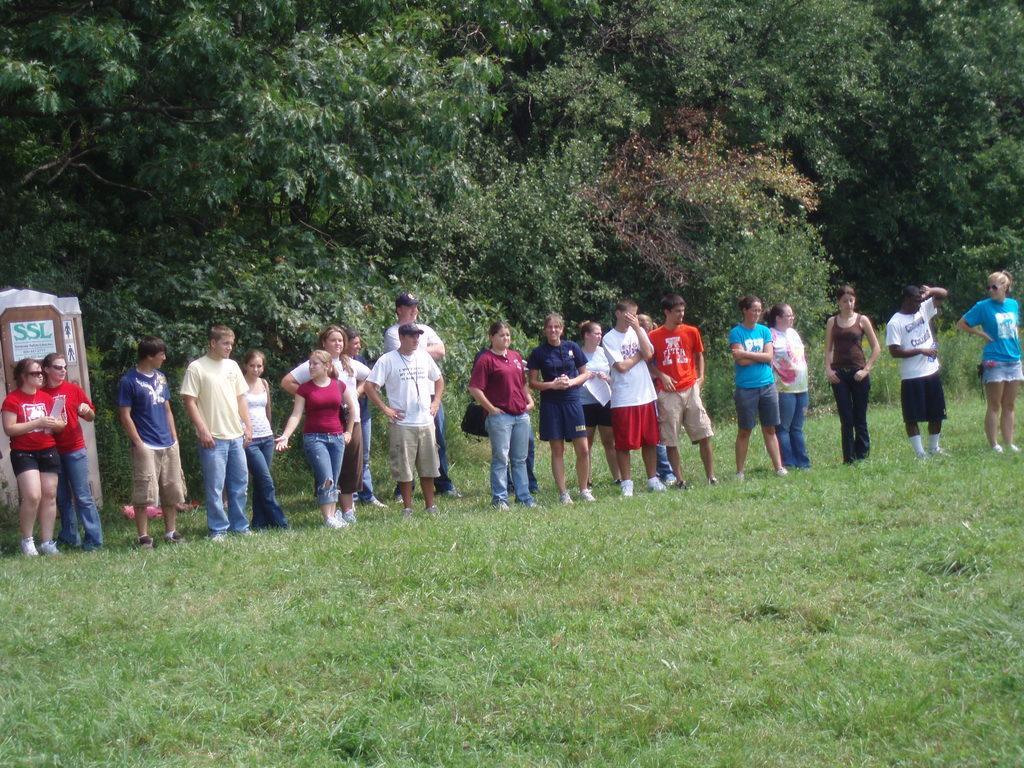Can you describe this image briefly? In this picture i can see a group of people are standing on the ground. On the left side i can see an object. In the background i can see trees and grass. 